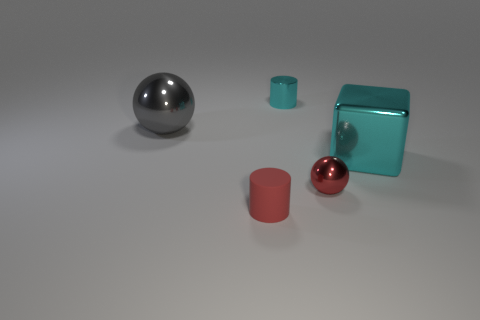Add 5 metal cylinders. How many objects exist? 10 Subtract 0 yellow blocks. How many objects are left? 5 Subtract all cubes. How many objects are left? 4 Subtract all big blue matte objects. Subtract all large metal things. How many objects are left? 3 Add 1 small balls. How many small balls are left? 2 Add 1 green cylinders. How many green cylinders exist? 1 